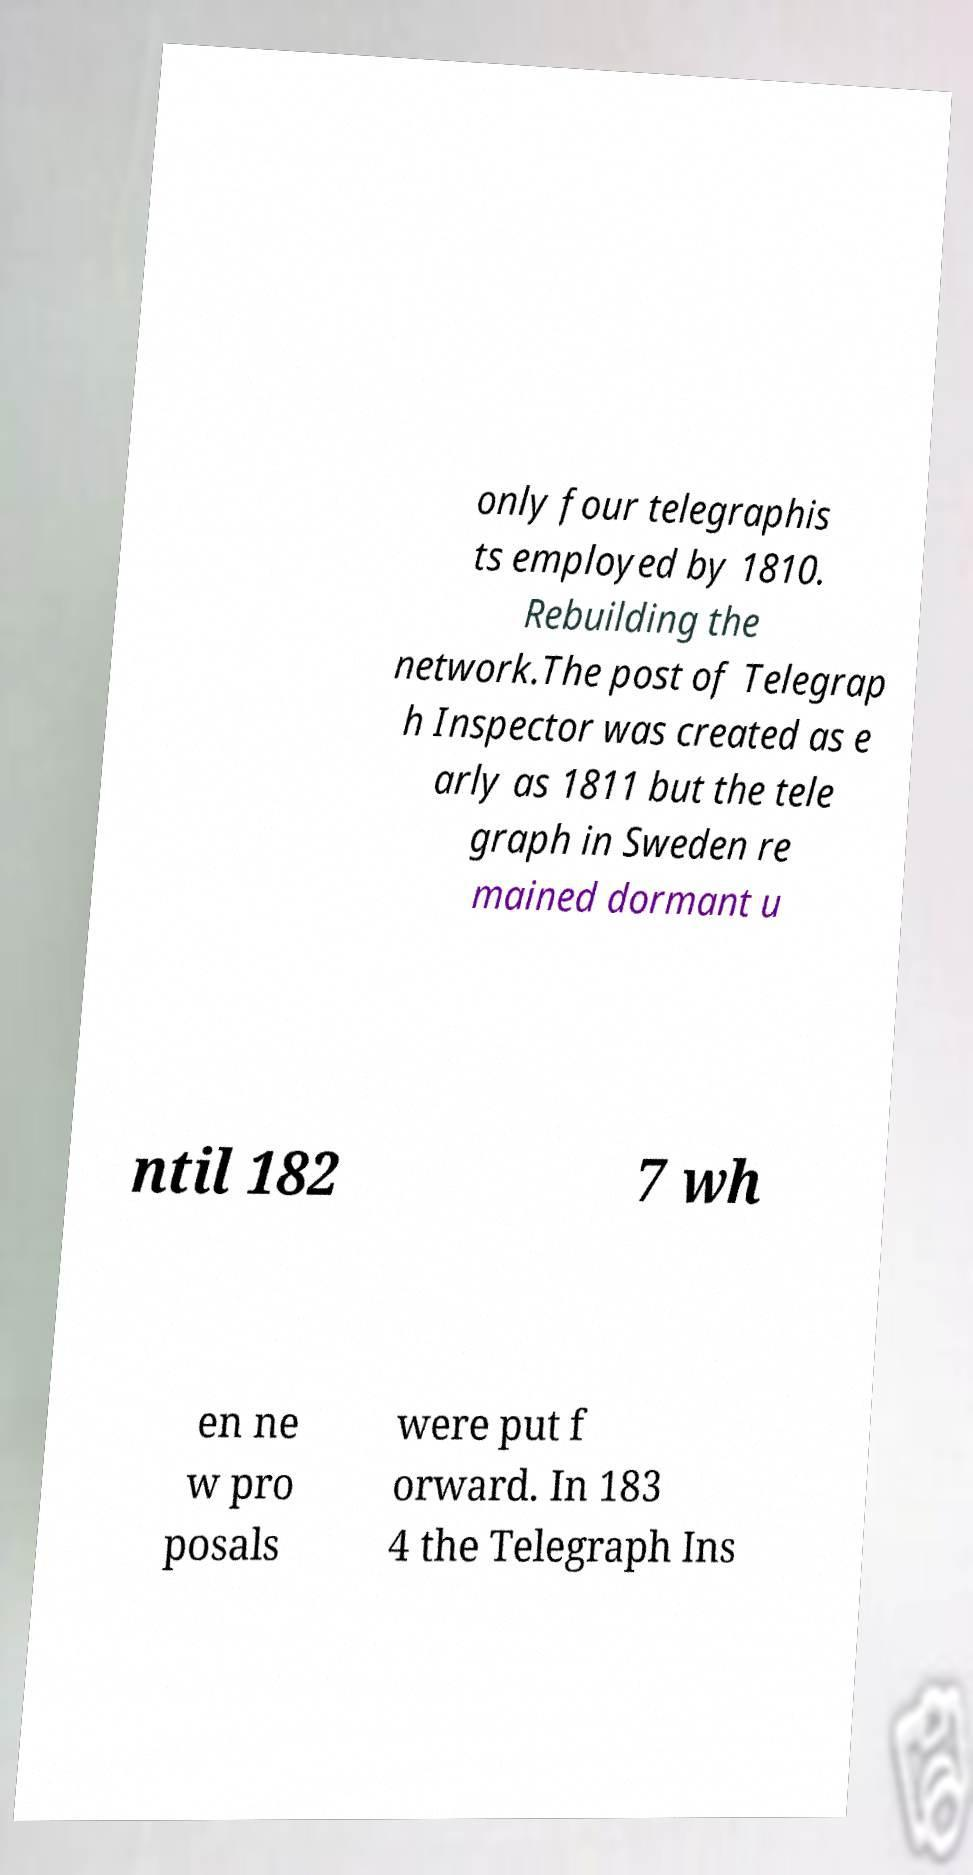Can you read and provide the text displayed in the image?This photo seems to have some interesting text. Can you extract and type it out for me? only four telegraphis ts employed by 1810. Rebuilding the network.The post of Telegrap h Inspector was created as e arly as 1811 but the tele graph in Sweden re mained dormant u ntil 182 7 wh en ne w pro posals were put f orward. In 183 4 the Telegraph Ins 